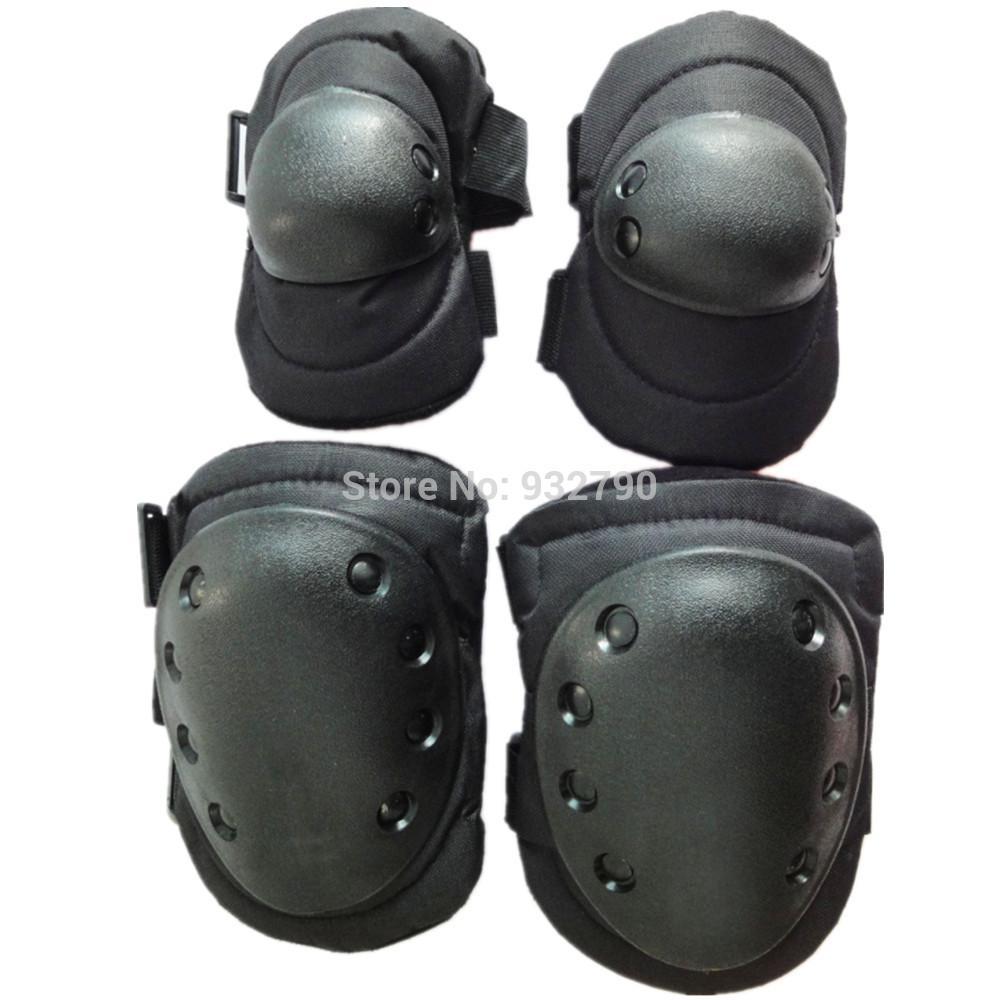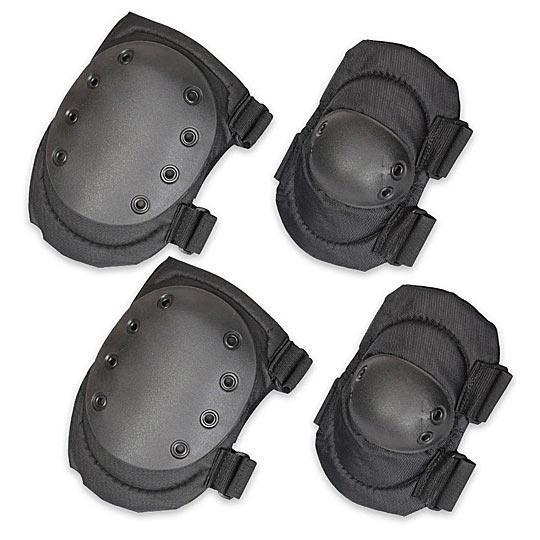The first image is the image on the left, the second image is the image on the right. For the images shown, is this caption "At least one image in the set contains exactly four kneepads, with no lettering on them or brand names." true? Answer yes or no. Yes. The first image is the image on the left, the second image is the image on the right. Given the left and right images, does the statement "There are at least eight pieces of black gear featured." hold true? Answer yes or no. Yes. 